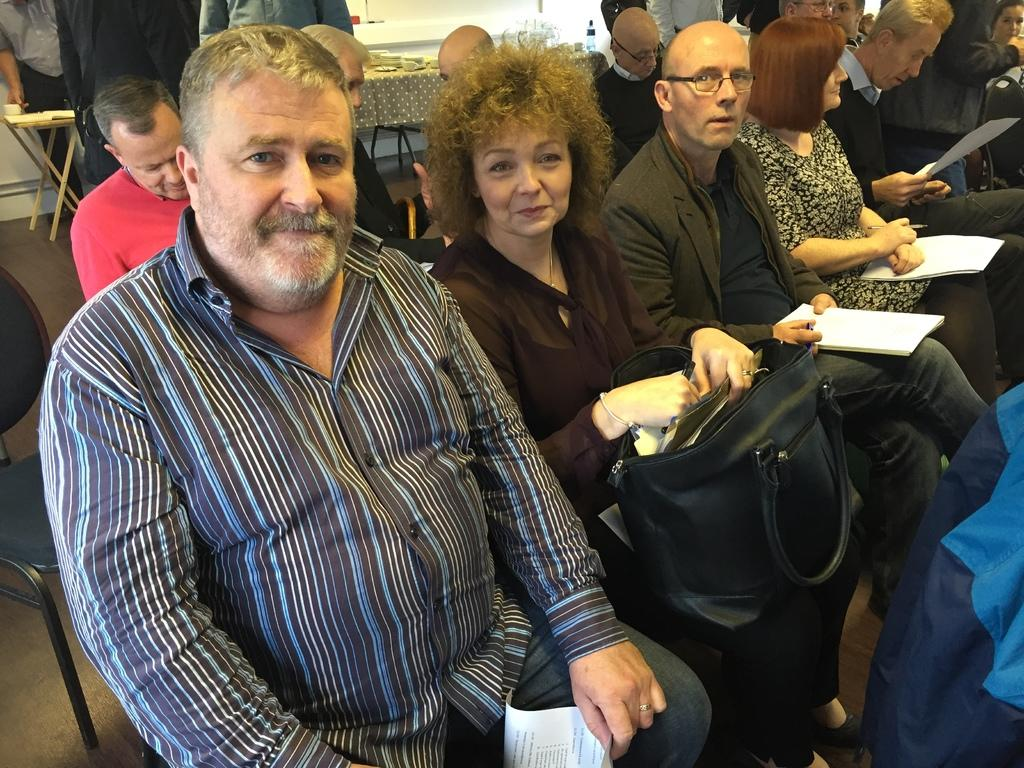What are the people in the image doing? The people in the image are sitting on chairs. What objects are the people holding in their hands? The people are holding books and bags in their hands. Can you describe the background of the image? There is a table visible in the background of the image. What type of flower is growing in the shade in the image? There is no flower or shade present in the image; it features people sitting on chairs holding books and bags. 